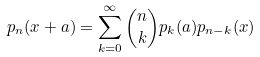Convert formula to latex. <formula><loc_0><loc_0><loc_500><loc_500>p _ { n } ( x + a ) = \sum _ { k = 0 } ^ { \infty } { n \choose k } p _ { k } ( a ) p _ { n - k } ( x )</formula> 